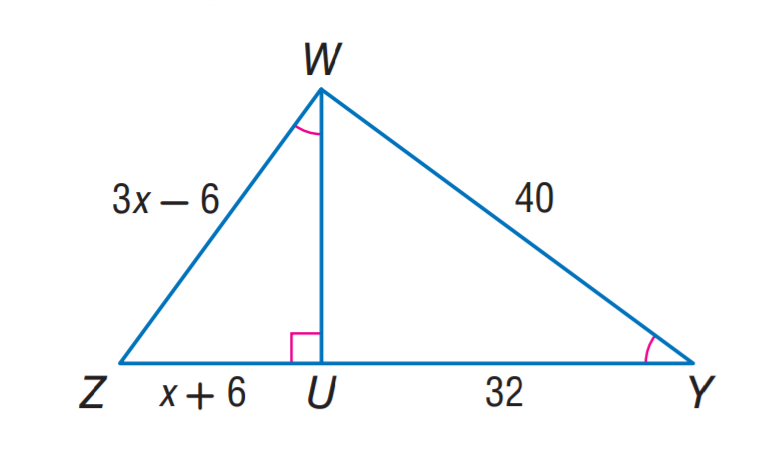Answer the mathemtical geometry problem and directly provide the correct option letter.
Question: Find U Z.
Choices: A: 12 B: 18 C: 24 D: 32 B 